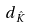Convert formula to latex. <formula><loc_0><loc_0><loc_500><loc_500>d _ { \hat { K } }</formula> 